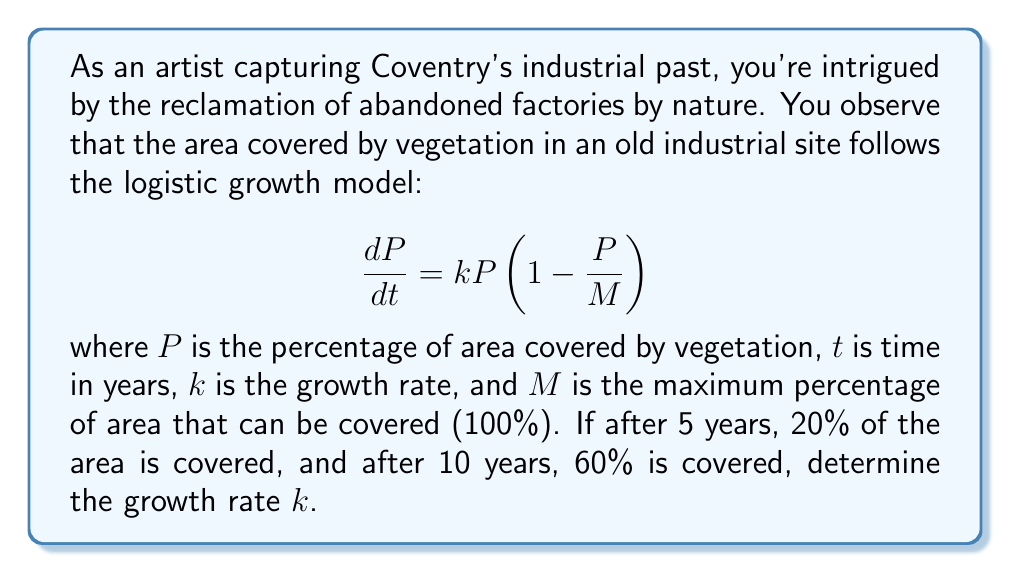Teach me how to tackle this problem. To solve this problem, we'll use the solution to the logistic differential equation:

$$P(t) = \frac{M}{1 + Ce^{-kt}}$$

where $C$ is a constant determined by initial conditions.

1) First, we know that $M = 100$ since it represents the maximum percentage.

2) We have two data points:
   At $t = 5$, $P = 20$
   At $t = 10$, $P = 60$

3) Let's use the first data point to find $C$:

   $$20 = \frac{100}{1 + Ce^{-5k}}$$

   $$5 = 1 + Ce^{-5k}$$

   $$C = 4e^{5k}$$

4) Now, let's use the second data point:

   $$60 = \frac{100}{1 + 4e^{5k}e^{-10k}}$$

   $$\frac{5}{3} = 1 + 4e^{-5k}$$

   $$\frac{2}{3} = 4e^{-5k}$$

   $$e^{-5k} = \frac{1}{6}$$

5) Taking the natural log of both sides:

   $$-5k = \ln(\frac{1}{6})$$

   $$k = -\frac{1}{5}\ln(\frac{1}{6}) = \frac{1}{5}\ln(6)$$

6) Calculate the value:

   $$k = \frac{1}{5}\ln(6) \approx 0.3577$$
Answer: The growth rate $k$ is approximately $0.3577$ per year. 